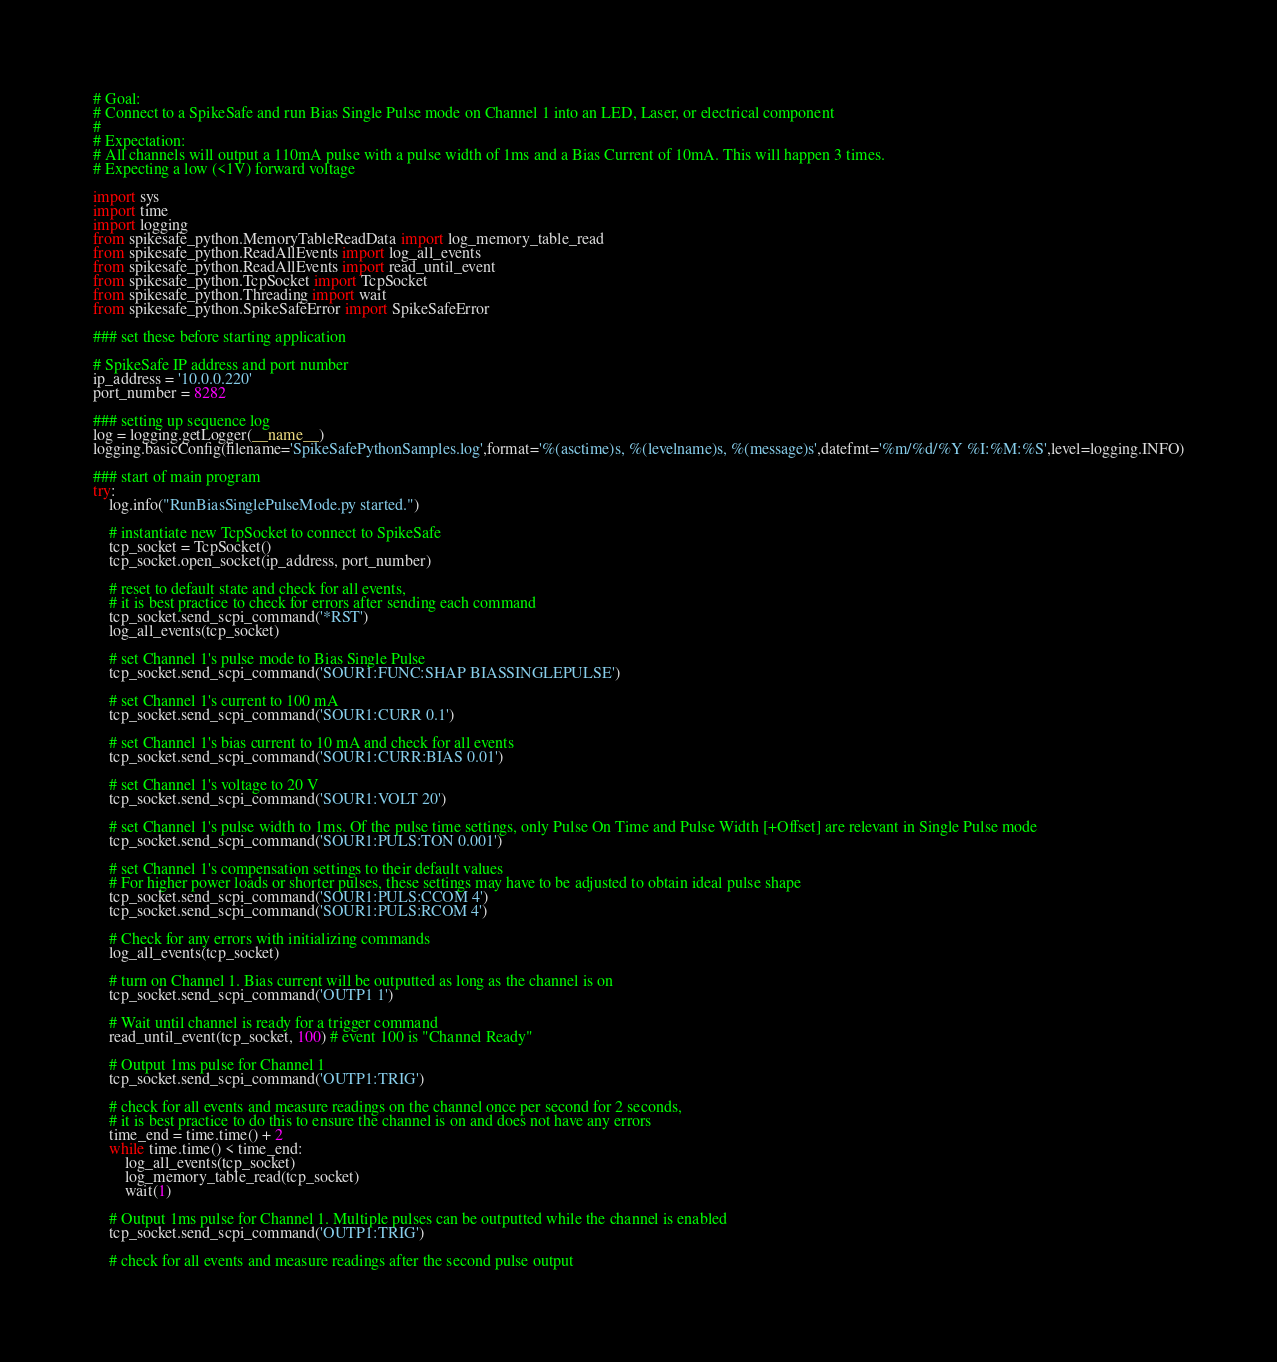Convert code to text. <code><loc_0><loc_0><loc_500><loc_500><_Python_># Goal: 
# Connect to a SpikeSafe and run Bias Single Pulse mode on Channel 1 into an LED, Laser, or electrical component
# 
# Expectation: 
# All channels will output a 110mA pulse with a pulse width of 1ms and a Bias Current of 10mA. This will happen 3 times. 
# Expecting a low (<1V) forward voltage

import sys
import time
import logging
from spikesafe_python.MemoryTableReadData import log_memory_table_read
from spikesafe_python.ReadAllEvents import log_all_events
from spikesafe_python.ReadAllEvents import read_until_event
from spikesafe_python.TcpSocket import TcpSocket
from spikesafe_python.Threading import wait    
from spikesafe_python.SpikeSafeError import SpikeSafeError 

### set these before starting application

# SpikeSafe IP address and port number
ip_address = '10.0.0.220'
port_number = 8282          

### setting up sequence log
log = logging.getLogger(__name__)
logging.basicConfig(filename='SpikeSafePythonSamples.log',format='%(asctime)s, %(levelname)s, %(message)s',datefmt='%m/%d/%Y %I:%M:%S',level=logging.INFO)

### start of main program
try:
    log.info("RunBiasSinglePulseMode.py started.")
    
    # instantiate new TcpSocket to connect to SpikeSafe
    tcp_socket = TcpSocket()
    tcp_socket.open_socket(ip_address, port_number)

    # reset to default state and check for all events,
    # it is best practice to check for errors after sending each command      
    tcp_socket.send_scpi_command('*RST')                  
    log_all_events(tcp_socket)

    # set Channel 1's pulse mode to Bias Single Pulse
    tcp_socket.send_scpi_command('SOUR1:FUNC:SHAP BIASSINGLEPULSE')

    # set Channel 1's current to 100 mA
    tcp_socket.send_scpi_command('SOUR1:CURR 0.1')

    # set Channel 1's bias current to 10 mA and check for all events
    tcp_socket.send_scpi_command('SOUR1:CURR:BIAS 0.01')     

    # set Channel 1's voltage to 20 V 
    tcp_socket.send_scpi_command('SOUR1:VOLT 20')   

    # set Channel 1's pulse width to 1ms. Of the pulse time settings, only Pulse On Time and Pulse Width [+Offset] are relevant in Single Pulse mode
    tcp_socket.send_scpi_command('SOUR1:PULS:TON 0.001')

    # set Channel 1's compensation settings to their default values
    # For higher power loads or shorter pulses, these settings may have to be adjusted to obtain ideal pulse shape
    tcp_socket.send_scpi_command('SOUR1:PULS:CCOM 4')
    tcp_socket.send_scpi_command('SOUR1:PULS:RCOM 4')   

    # Check for any errors with initializing commands
    log_all_events(tcp_socket)

    # turn on Channel 1. Bias current will be outputted as long as the channel is on
    tcp_socket.send_scpi_command('OUTP1 1')

    # Wait until channel is ready for a trigger command
    read_until_event(tcp_socket, 100) # event 100 is "Channel Ready"

    # Output 1ms pulse for Channel 1
    tcp_socket.send_scpi_command('OUTP1:TRIG')

    # check for all events and measure readings on the channel once per second for 2 seconds,
    # it is best practice to do this to ensure the channel is on and does not have any errors
    time_end = time.time() + 2                         
    while time.time() < time_end:                       
        log_all_events(tcp_socket)
        log_memory_table_read(tcp_socket)
        wait(1)        

    # Output 1ms pulse for Channel 1. Multiple pulses can be outputted while the channel is enabled
    tcp_socket.send_scpi_command('OUTP1:TRIG')

    # check for all events and measure readings after the second pulse output</code> 